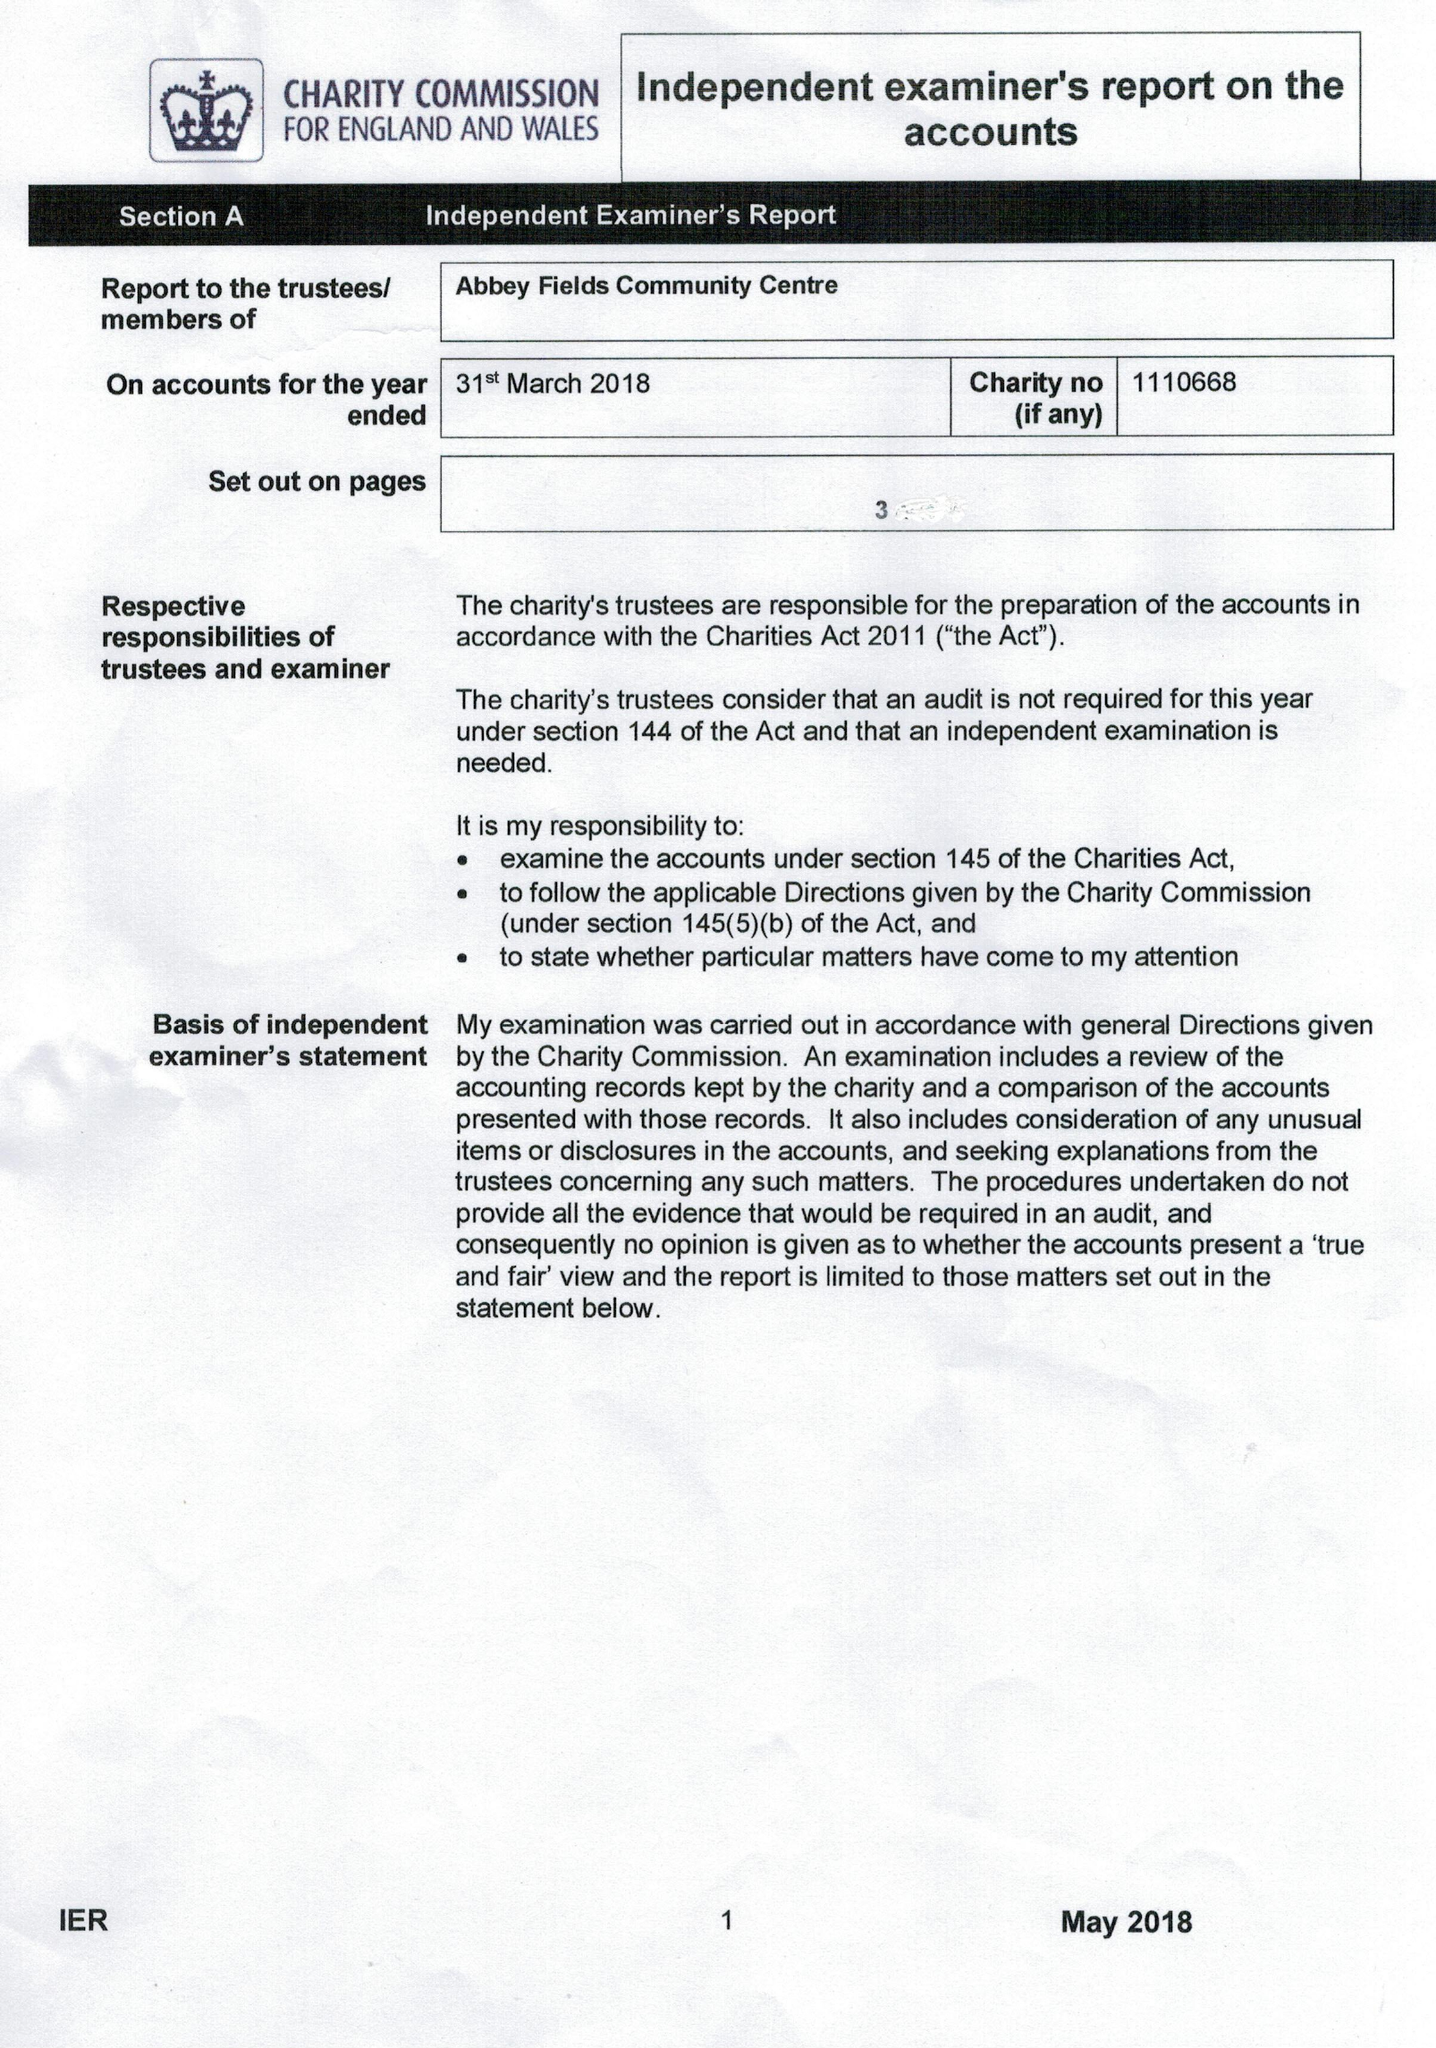What is the value for the spending_annually_in_british_pounds?
Answer the question using a single word or phrase. 20492.00 